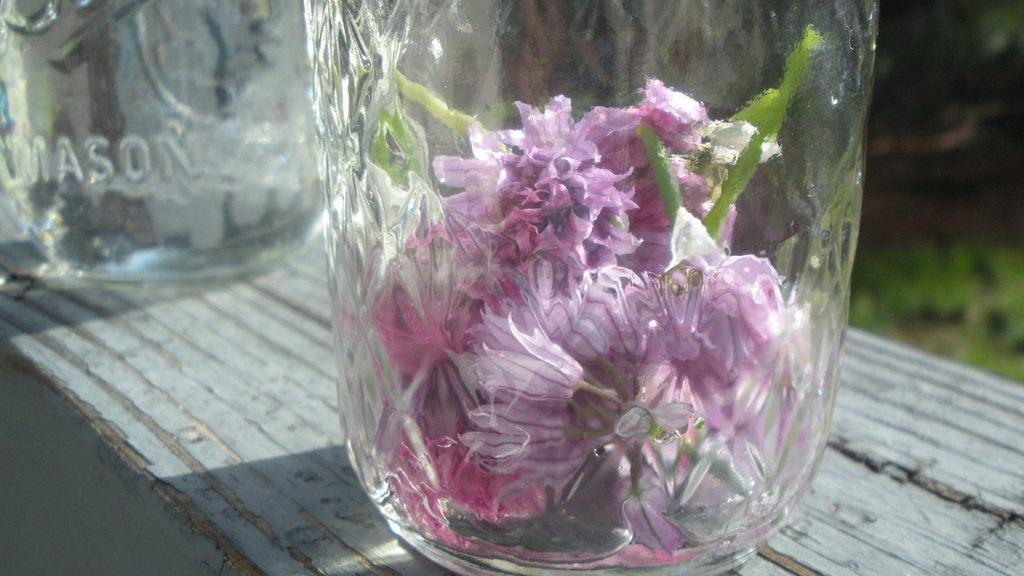What type of objects are hanging on the wall in the image? There are glass objects on a wall in the image. What can be seen inside the glass objects? There are flowers inside the glass objects. Can you describe the background of the image? The background of the image is blurred. What type of bird can be seen flying near the seashore in the image? There is no bird or seashore present in the image; it features glass objects with flowers on a wall, and the background is blurred. 